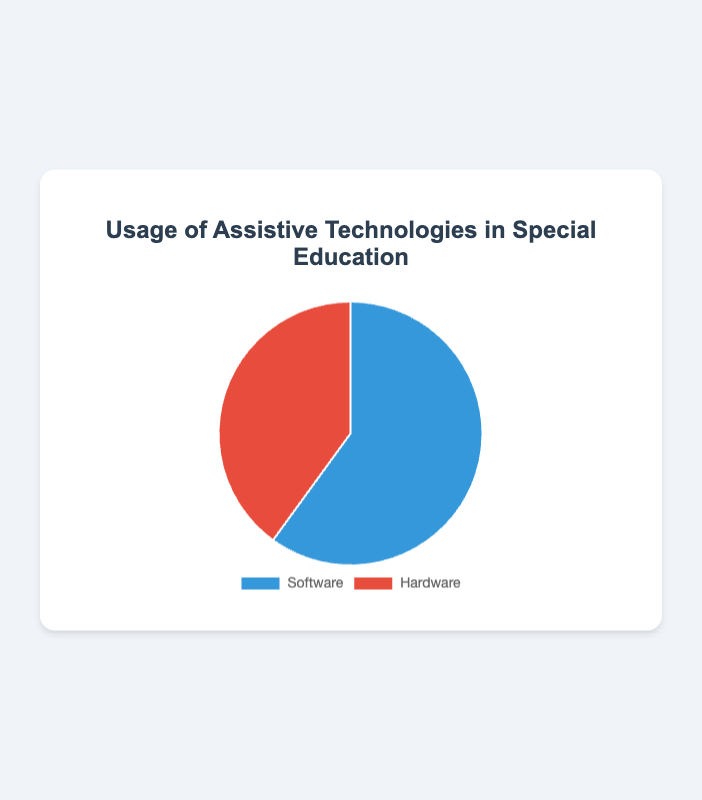What percentage of the special education budget is allocated to traditional teaching methods? The pie chart shows the proportion of the special education budget allocated to different methods. Traditional teaching methods receive 65% of the budget.
Answer: 65% What category has the highest budget allocation in special education? By comparing the two slices of the pie chart, the "Traditional Teaching Methods" slice is larger than the "Technology" slice, indicating it has the highest allocation.
Answer: Traditional Teaching Methods What's the difference in the amount spent on traditional teaching methods and technology? The chart indicates 65% is spent on traditional methods and 35% on technology. We can calculate the difference as 65% - 35% = 30%. Alternatively, in terms of dollar amounts: $65,000 - $35,000 = $30,000.
Answer: $30,000 What percentage of assistive technology usage is attributed to software? The pie chart of assistive technology usage shows that 60% is attributed to software.
Answer: 60% How does the usage of software compare to hardware in assistive technology within special education? The pie chart shows that 60% of assistive technology usage is software, which is more than the 40% used by hardware.
Answer: Software usage is higher What is the total budget allocated to special education according to the pie chart? The total budget is represented by the sum of the slices of the pie chart: $100,000.
Answer: $100,000 Which category in assistive technology has the smallest usage proportion? By comparing the two slices of the assistive technology usage pie chart, the "Hardware" slice is smaller than the "Software" slice.
Answer: Hardware How much total assistive technology usage is depicted in the pie chart? The chart indicates a total assistive technology usage of 100 units.
Answer: 100 units What is the ratio of software to hardware usage in assistive technology? The chart shows software usage at 60 and hardware at 40. The ratio is 60:40, which can be simplified to 3:2.
Answer: 3:2 How much more is spent on special education traditional teaching methods compared to technology in percentage terms? The chart shows 65% is allocated to traditional methods and 35% to technology: 65% - 35% = 30% more.
Answer: 30% more 